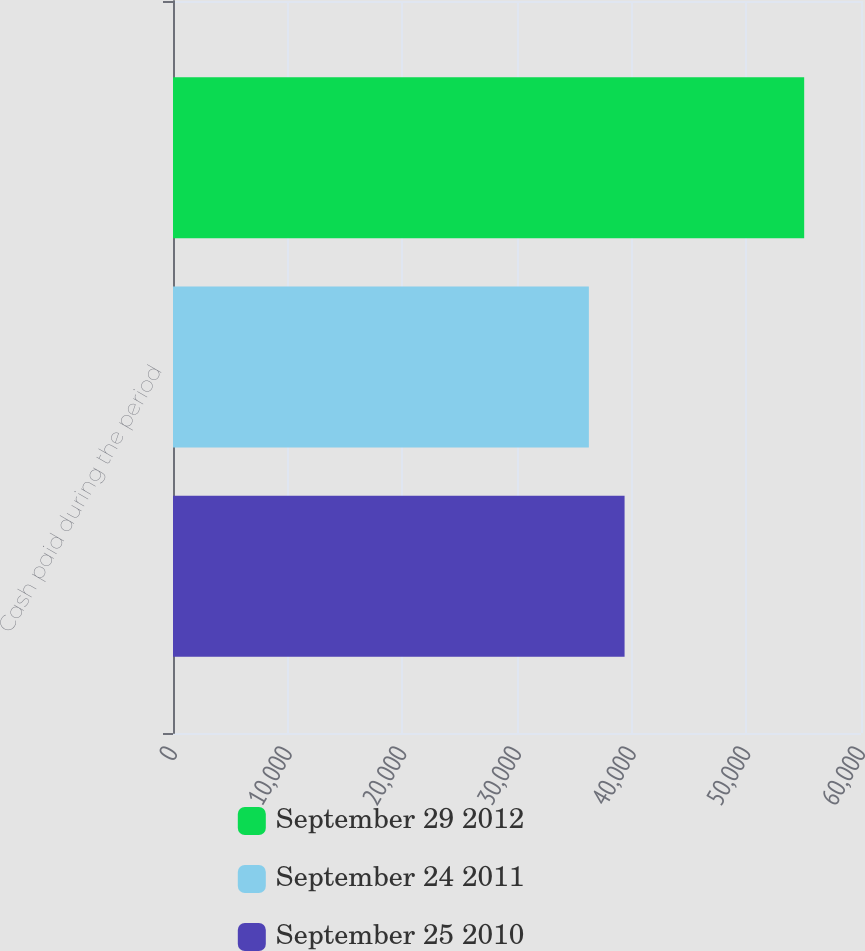Convert chart to OTSL. <chart><loc_0><loc_0><loc_500><loc_500><stacked_bar_chart><ecel><fcel>Cash paid during the period<nl><fcel>September 29 2012<fcel>55045<nl><fcel>September 24 2011<fcel>36268<nl><fcel>September 25 2010<fcel>39382<nl></chart> 